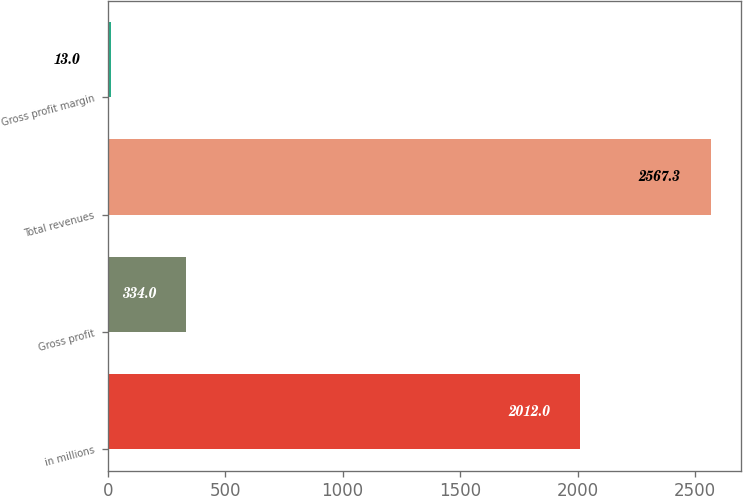<chart> <loc_0><loc_0><loc_500><loc_500><bar_chart><fcel>in millions<fcel>Gross profit<fcel>Total revenues<fcel>Gross profit margin<nl><fcel>2012<fcel>334<fcel>2567.3<fcel>13<nl></chart> 